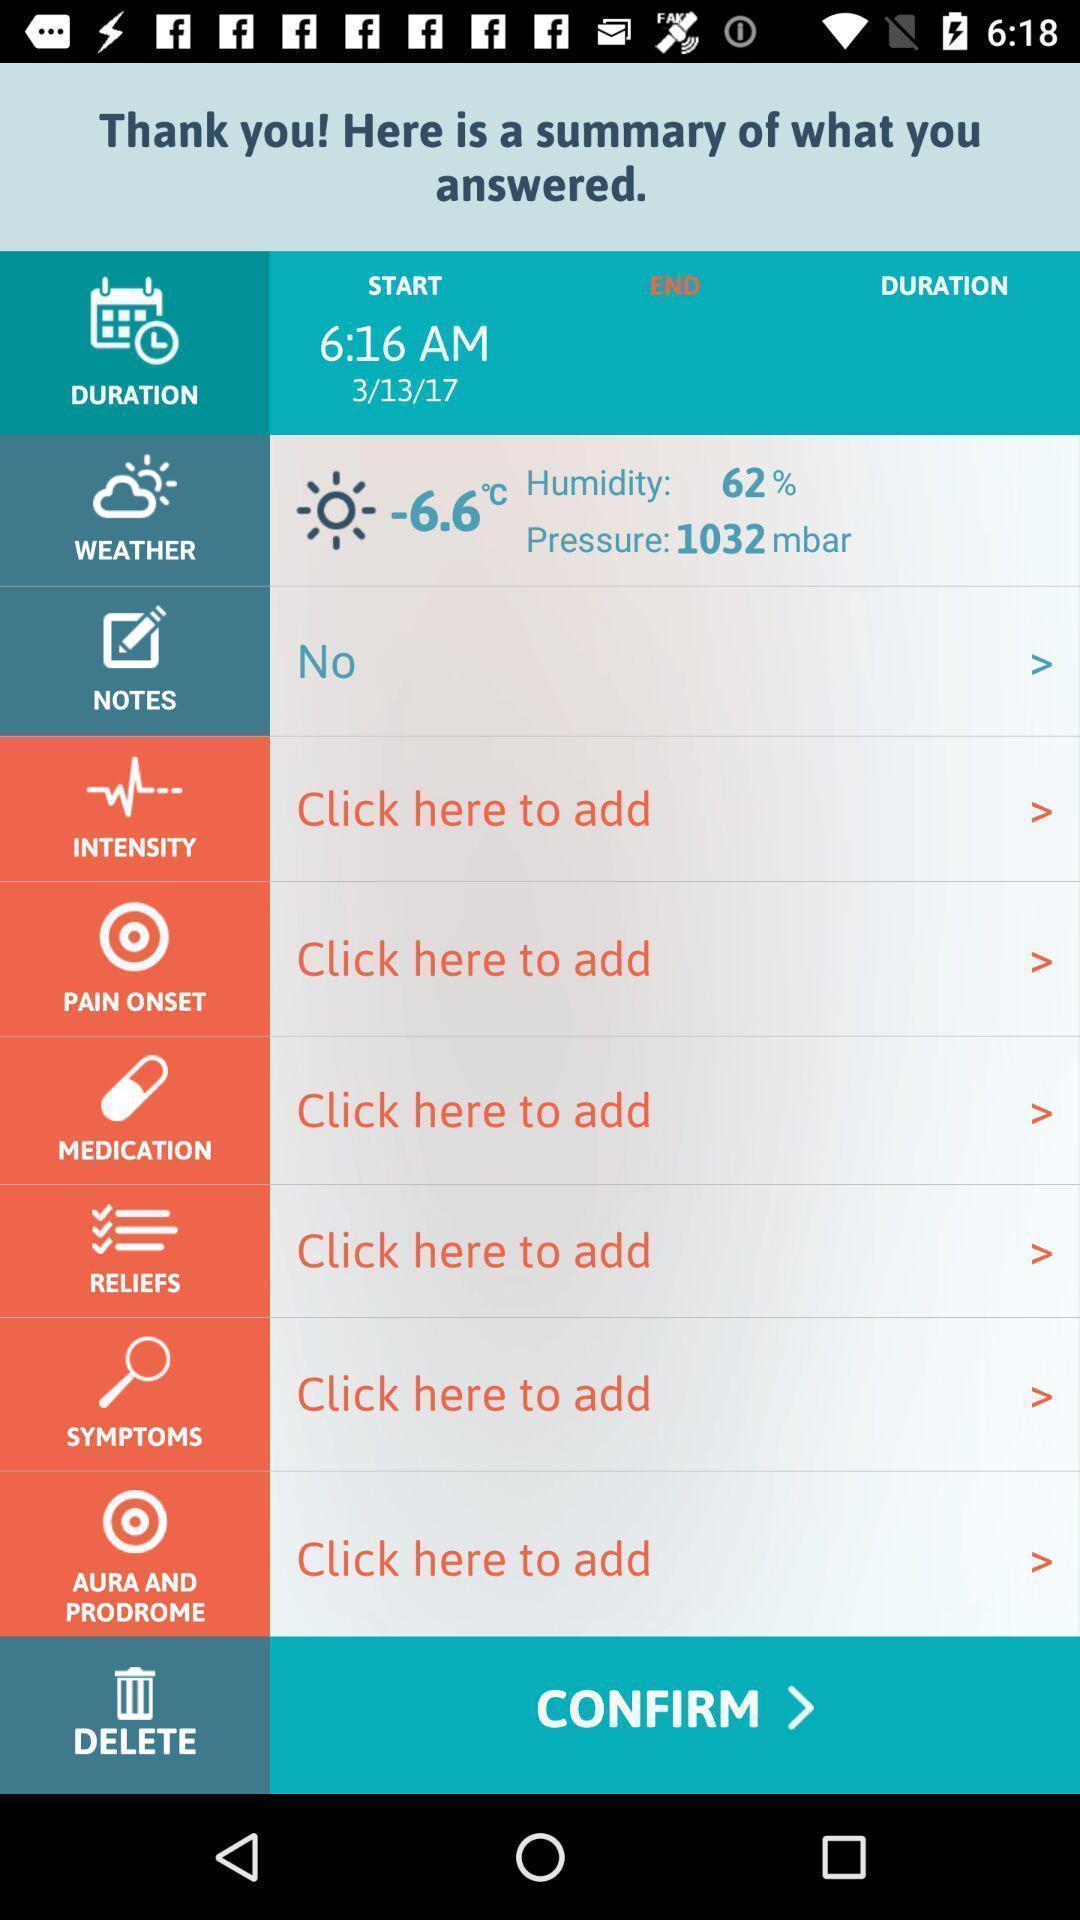What details can you identify in this image? Screen page displaying various options. 